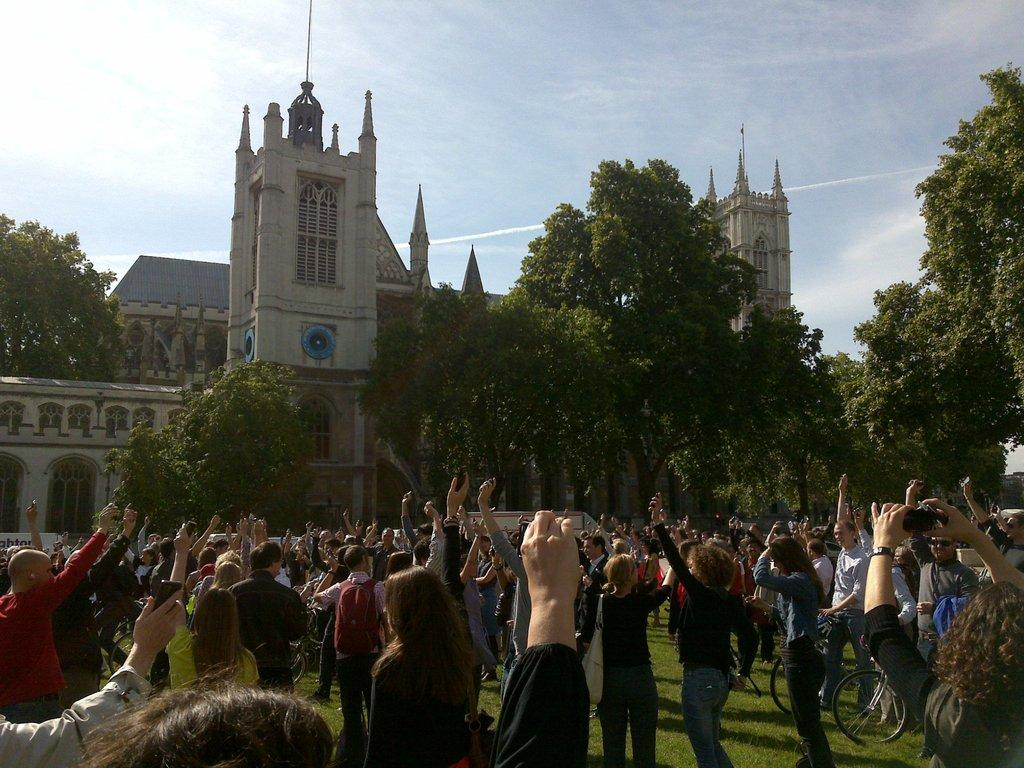What is happening in the foreground of the image? There is a group of people standing on the ground. What can be seen in the background of the image? There are bicycles, trees, buildings, grass, and the sky visible in the background. Can you describe the setting of the image? The image appears to be set in an outdoor area with a mix of natural and man-made elements. What type of story is being told by the people in the image? There is no indication of a story being told in the image; it simply shows a group of people standing on the ground. Can you describe the salt content in the image? There is no salt present in the image. 